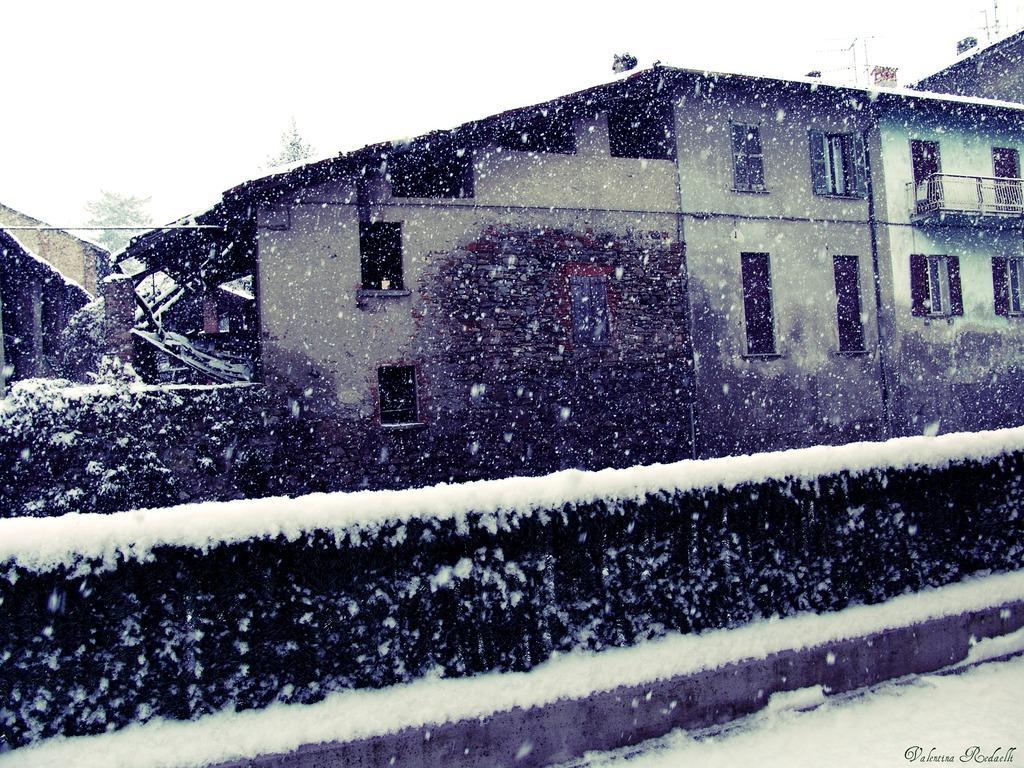In one or two sentences, can you explain what this image depicts? This image consists of buildings. In the front, we can see the plants covered with the snow. At the bottom, there is a road. At the top, there is sky. 